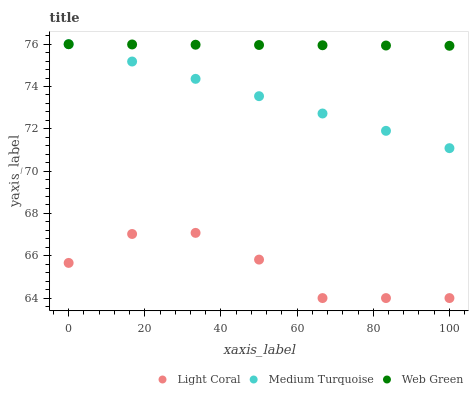Does Light Coral have the minimum area under the curve?
Answer yes or no. Yes. Does Web Green have the maximum area under the curve?
Answer yes or no. Yes. Does Medium Turquoise have the minimum area under the curve?
Answer yes or no. No. Does Medium Turquoise have the maximum area under the curve?
Answer yes or no. No. Is Medium Turquoise the smoothest?
Answer yes or no. Yes. Is Light Coral the roughest?
Answer yes or no. Yes. Is Web Green the smoothest?
Answer yes or no. No. Is Web Green the roughest?
Answer yes or no. No. Does Light Coral have the lowest value?
Answer yes or no. Yes. Does Medium Turquoise have the lowest value?
Answer yes or no. No. Does Medium Turquoise have the highest value?
Answer yes or no. Yes. Is Light Coral less than Medium Turquoise?
Answer yes or no. Yes. Is Medium Turquoise greater than Light Coral?
Answer yes or no. Yes. Does Web Green intersect Medium Turquoise?
Answer yes or no. Yes. Is Web Green less than Medium Turquoise?
Answer yes or no. No. Is Web Green greater than Medium Turquoise?
Answer yes or no. No. Does Light Coral intersect Medium Turquoise?
Answer yes or no. No. 